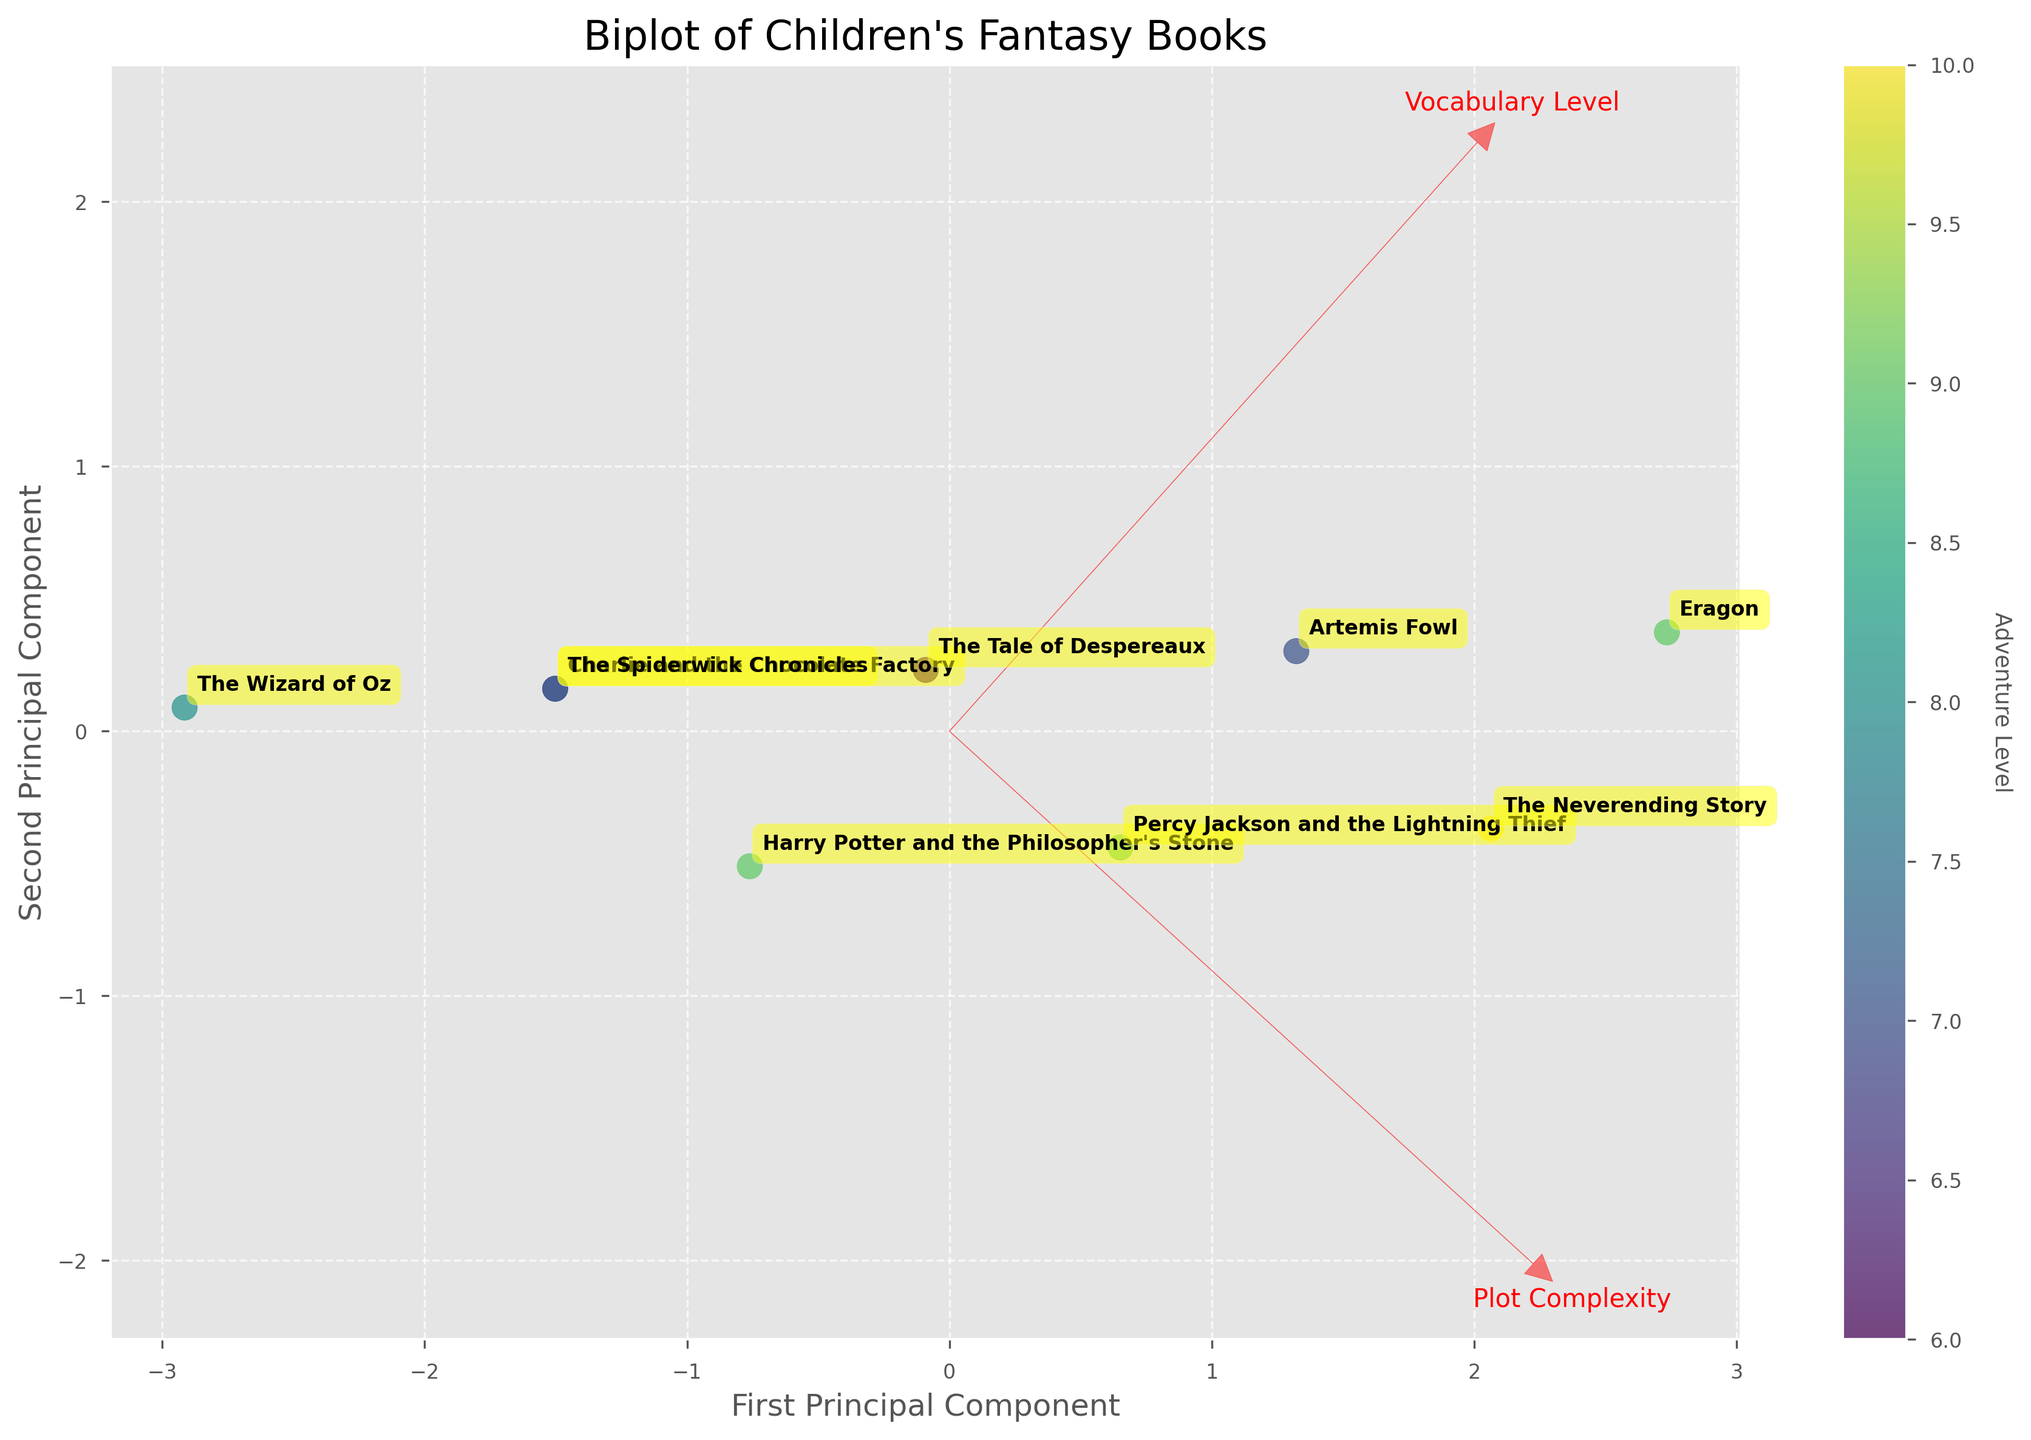What is the title of the biplot? The title of a plot is typically found at the top and is often the largest text. The biplot's title is "Biplot of Children's Fantasy Books".
Answer: Biplot of Children's Fantasy Books How many books are depicted in the biplot? The number of books can be determined by counting the number of annotated book titles in the plot. There are 9 book titles annotated.
Answer: 9 Which two books have the highest Adventure Level? To find this, look at the colorbar and seek out the points with the highest color intensity towards the "Adventure Level" end. The annotations reveal that "The Neverending Story" and "Percy Jackson and the Lightning Thief" have the highest Adventure Level (annotated near the top).
Answer: The Neverending Story, Percy Jackson and the Lightning Thief Which book has the highest combination of Plot Complexity and Vocabulary Level? To find the book with the highest combination, look at the projection in the plot. "Eragon" is positioned furthest along the first and second principal components, reflecting high values for both attributes.
Answer: Eragon Which feature has the largest vector magnitude? Observe the lengths of the red arrows in the plot. The feature with the arrow extending furthest from the origin (0,0) has the largest vector magnitude. The "Plot Complexity" vector appears to be longer.
Answer: Plot Complexity What is the color representing in this biplot? The colormap beside the plot (colorbar) shows how the point colors correspond to "Adventure Level". The label beside the color gradient indicates what is being represented.
Answer: Adventure Level Which book has a higher Vocabulary Level, "Harry Potter and the Philosopher's Stone" or "The Tale of Despereaux"? Compare the position of the two books in relation to the second principal component (related to Vocabulary Level). "The Tale of Despereaux" is positioned higher than "Harry Potter and the Philosopher's Stone" along this axis.
Answer: The Tale of Despereaux Which books are closely related in terms of Plot Complexity and Vocabulary Level and are positioned near each other in the biplot? Look for clusters or closely positioned points to identify similar books. "The Spiderwick Chronicles" and "Charlie and the Chocolate Factory" are closely positioned, indicating similarity in Plot Complexity and Vocabulary Level.
Answer: The Spiderwick Chronicles, Charlie and the Chocolate Factory What direction does the vector for "Vocabulary Level" point to, and what does it indicate? Inspect the red arrow labeled "Vocabulary Level". It points towards the top, suggesting that as you move upward in the second principal component, the Vocabulary Level increases. This indicates higher values for Vocabulary Level in that direction.
Answer: Upward (indicating increasing Vocabulary Level) What does a point on the lower left of the biplot represent? A point near the lower left represents a book with relatively lower Plot Complexity and Vocabulary Level since the directions of the principal components indicate these features. These books are simpler and have less complex vocabularies.
Answer: Lower Plot Complexity and Vocabulary Level 